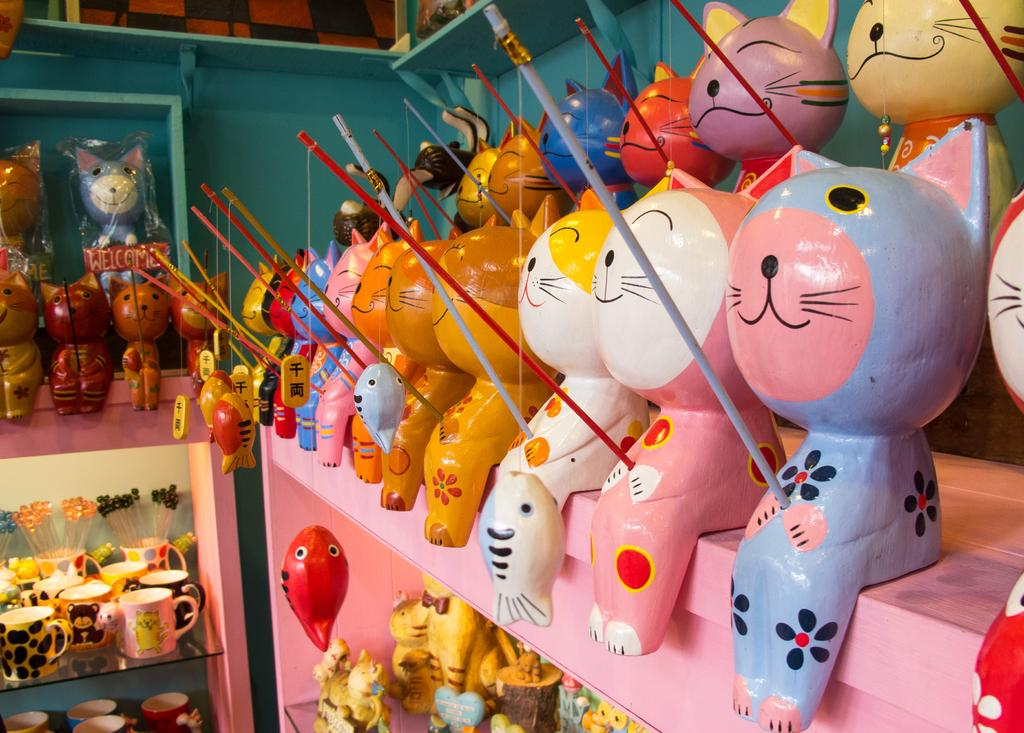What type of objects can be seen in the image? There are toys and cups in racks visible in the image. What else can be seen in the image? There are sticks visible in the image. What is visible in the background of the image? There is a wall in the background of the image. What type of sofa can be seen in the image? There is no sofa present in the image. What type of mine is visible in the image? There is no mine present in the image. 